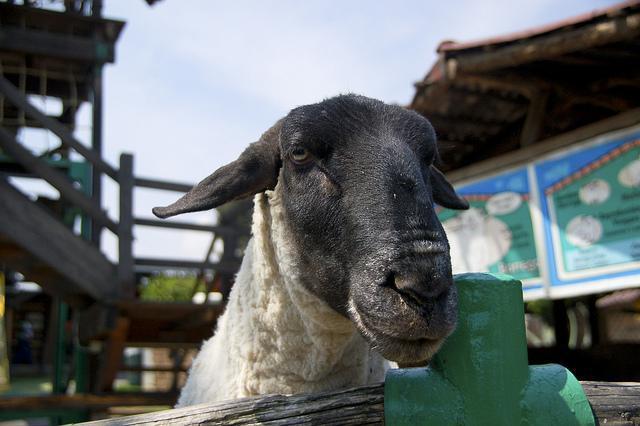How many animals?
Give a very brief answer. 1. How many of the buses are blue?
Give a very brief answer. 0. 